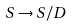Convert formula to latex. <formula><loc_0><loc_0><loc_500><loc_500>S \rightarrow S / D</formula> 